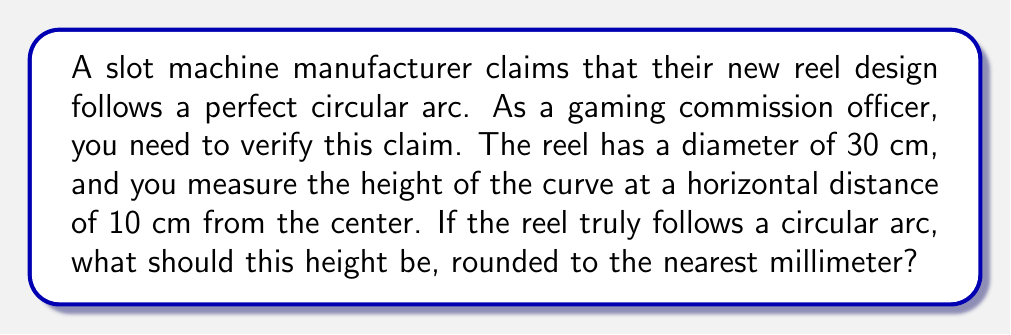Give your solution to this math problem. To solve this problem, we need to use the equation of a circle and some trigonometric concepts. Let's approach this step-by-step:

1) The equation of a circle with radius $r$ centered at the origin is:

   $$x^2 + y^2 = r^2$$

2) In this case, the radius is half the diameter: $r = 15$ cm.

3) We're measuring at a horizontal distance of 10 cm from the center, so $x = 10$.

4) Substituting these values into the circle equation:

   $$10^2 + y^2 = 15^2$$

5) Simplify:

   $$100 + y^2 = 225$$

6) Solve for $y$:

   $$y^2 = 225 - 100 = 125$$
   $$y = \sqrt{125}$$

7) This gives us the total height from the x-axis to the top of the circle. However, we want the height from the bottom of the circle to this point, which is twice this value:

   $$\text{height} = 2\sqrt{125}$$

8) Simplify:

   $$\text{height} = 2\sqrt{25 \cdot 5} = 2 \cdot 5 \sqrt{5} = 10\sqrt{5} \approx 22.36068$$

9) Rounding to the nearest millimeter:

   $$\text{height} \approx 22.4 \text{ cm}$$

This approach uses the geometric properties of a circle. Alternatively, we could have used the inverse sine function:

$$\text{height} = r - r\cos(\arcsin(10/15)) \approx 22.4 \text{ cm}$$

Both methods yield the same result, confirming our calculation.
Answer: 22.4 cm 